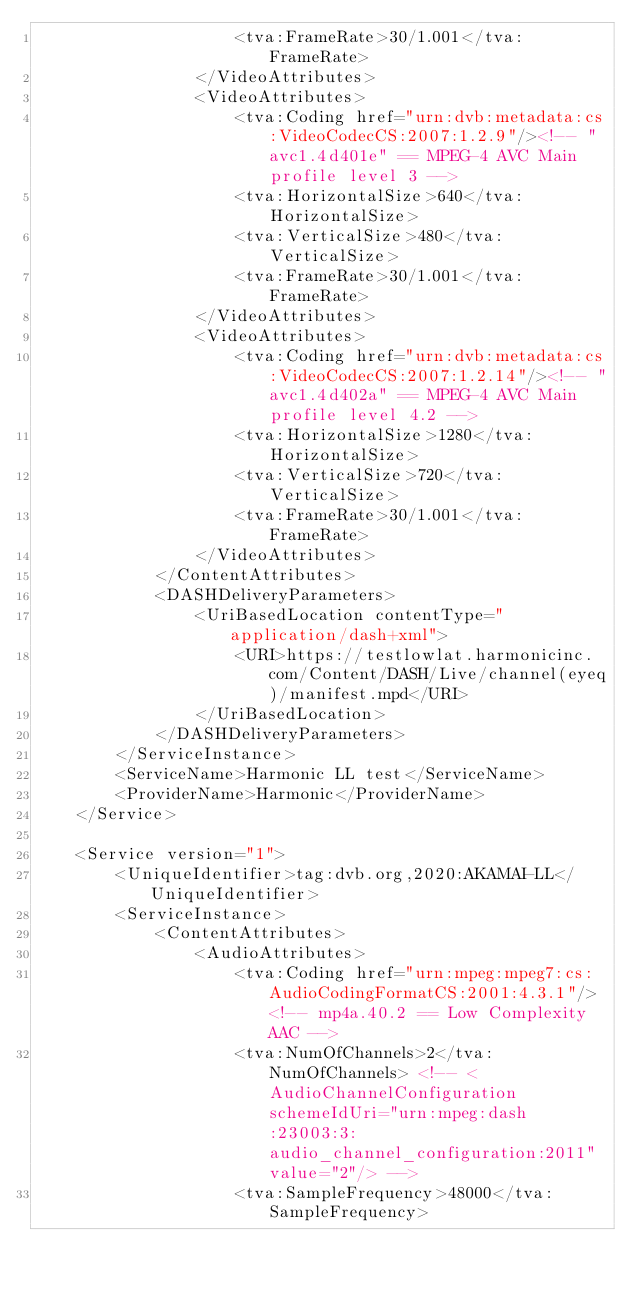<code> <loc_0><loc_0><loc_500><loc_500><_XML_>					<tva:FrameRate>30/1.001</tva:FrameRate>
				</VideoAttributes>
				<VideoAttributes>
					<tva:Coding href="urn:dvb:metadata:cs:VideoCodecCS:2007:1.2.9"/><!-- "avc1.4d401e" == MPEG-4 AVC Main profile level 3 -->
					<tva:HorizontalSize>640</tva:HorizontalSize>
					<tva:VerticalSize>480</tva:VerticalSize>
					<tva:FrameRate>30/1.001</tva:FrameRate>
				</VideoAttributes>
				<VideoAttributes>
					<tva:Coding href="urn:dvb:metadata:cs:VideoCodecCS:2007:1.2.14"/><!-- "avc1.4d402a" == MPEG-4 AVC Main profile level 4.2 -->
					<tva:HorizontalSize>1280</tva:HorizontalSize>
					<tva:VerticalSize>720</tva:VerticalSize>
					<tva:FrameRate>30/1.001</tva:FrameRate>
				</VideoAttributes>
			</ContentAttributes>
			<DASHDeliveryParameters>
				<UriBasedLocation contentType="application/dash+xml">
					<URI>https://testlowlat.harmonicinc.com/Content/DASH/Live/channel(eyeq)/manifest.mpd</URI>
				</UriBasedLocation>
			</DASHDeliveryParameters>
		</ServiceInstance>
		<ServiceName>Harmonic LL test</ServiceName>
 		<ProviderName>Harmonic</ProviderName>
	</Service>
	
	<Service version="1">
		<UniqueIdentifier>tag:dvb.org,2020:AKAMAI-LL</UniqueIdentifier>
		<ServiceInstance>
			<ContentAttributes>
				<AudioAttributes>
					<tva:Coding href="urn:mpeg:mpeg7:cs:AudioCodingFormatCS:2001:4.3.1"/> <!-- mp4a.40.2 == Low Complexity AAC -->
					<tva:NumOfChannels>2</tva:NumOfChannels> <!-- <AudioChannelConfiguration schemeIdUri="urn:mpeg:dash:23003:3:audio_channel_configuration:2011" value="2"/> -->
					<tva:SampleFrequency>48000</tva:SampleFrequency></code> 